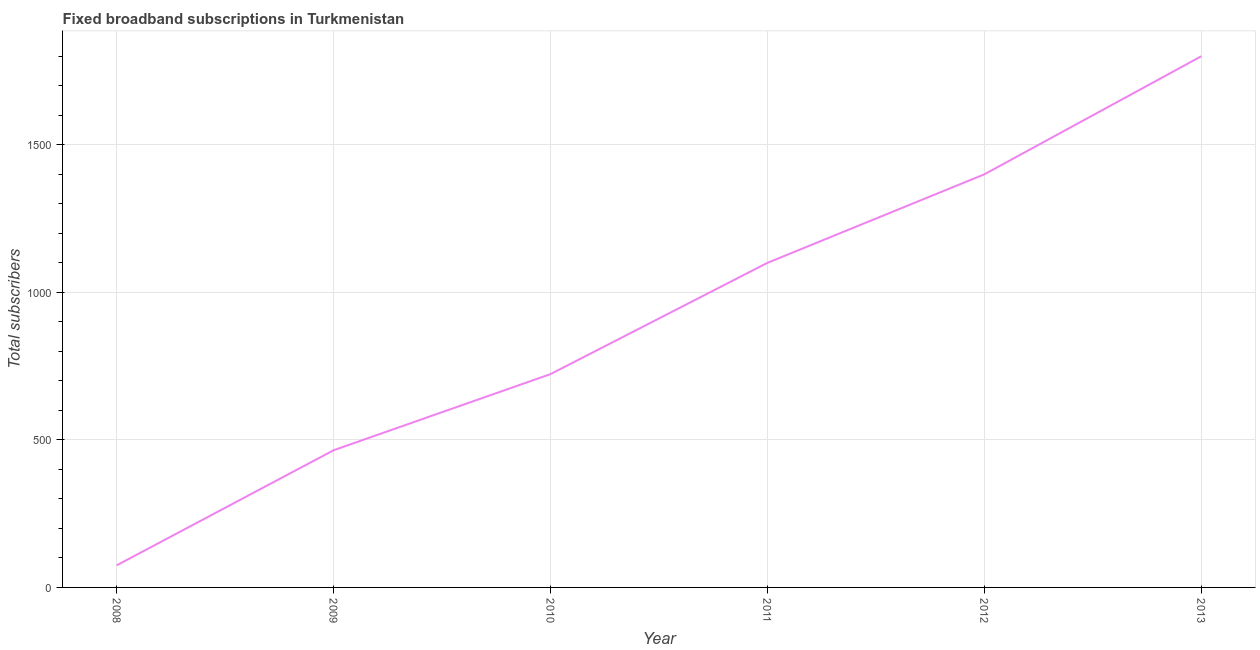What is the total number of fixed broadband subscriptions in 2010?
Your answer should be compact. 723. Across all years, what is the maximum total number of fixed broadband subscriptions?
Your answer should be very brief. 1800. Across all years, what is the minimum total number of fixed broadband subscriptions?
Provide a succinct answer. 75. In which year was the total number of fixed broadband subscriptions maximum?
Your answer should be compact. 2013. What is the sum of the total number of fixed broadband subscriptions?
Your answer should be very brief. 5563. What is the difference between the total number of fixed broadband subscriptions in 2008 and 2013?
Provide a succinct answer. -1725. What is the average total number of fixed broadband subscriptions per year?
Your response must be concise. 927.17. What is the median total number of fixed broadband subscriptions?
Keep it short and to the point. 911.5. What is the ratio of the total number of fixed broadband subscriptions in 2011 to that in 2012?
Your answer should be very brief. 0.79. Is the difference between the total number of fixed broadband subscriptions in 2008 and 2012 greater than the difference between any two years?
Provide a short and direct response. No. Is the sum of the total number of fixed broadband subscriptions in 2008 and 2010 greater than the maximum total number of fixed broadband subscriptions across all years?
Keep it short and to the point. No. What is the difference between the highest and the lowest total number of fixed broadband subscriptions?
Ensure brevity in your answer.  1725. In how many years, is the total number of fixed broadband subscriptions greater than the average total number of fixed broadband subscriptions taken over all years?
Provide a succinct answer. 3. Does the total number of fixed broadband subscriptions monotonically increase over the years?
Provide a succinct answer. Yes. How many lines are there?
Your response must be concise. 1. What is the difference between two consecutive major ticks on the Y-axis?
Give a very brief answer. 500. Are the values on the major ticks of Y-axis written in scientific E-notation?
Offer a terse response. No. What is the title of the graph?
Your response must be concise. Fixed broadband subscriptions in Turkmenistan. What is the label or title of the Y-axis?
Your answer should be compact. Total subscribers. What is the Total subscribers in 2009?
Ensure brevity in your answer.  465. What is the Total subscribers of 2010?
Your answer should be compact. 723. What is the Total subscribers of 2011?
Your answer should be very brief. 1100. What is the Total subscribers in 2012?
Your answer should be compact. 1400. What is the Total subscribers in 2013?
Give a very brief answer. 1800. What is the difference between the Total subscribers in 2008 and 2009?
Your answer should be very brief. -390. What is the difference between the Total subscribers in 2008 and 2010?
Make the answer very short. -648. What is the difference between the Total subscribers in 2008 and 2011?
Make the answer very short. -1025. What is the difference between the Total subscribers in 2008 and 2012?
Your answer should be very brief. -1325. What is the difference between the Total subscribers in 2008 and 2013?
Provide a succinct answer. -1725. What is the difference between the Total subscribers in 2009 and 2010?
Make the answer very short. -258. What is the difference between the Total subscribers in 2009 and 2011?
Make the answer very short. -635. What is the difference between the Total subscribers in 2009 and 2012?
Offer a very short reply. -935. What is the difference between the Total subscribers in 2009 and 2013?
Ensure brevity in your answer.  -1335. What is the difference between the Total subscribers in 2010 and 2011?
Give a very brief answer. -377. What is the difference between the Total subscribers in 2010 and 2012?
Ensure brevity in your answer.  -677. What is the difference between the Total subscribers in 2010 and 2013?
Your response must be concise. -1077. What is the difference between the Total subscribers in 2011 and 2012?
Offer a terse response. -300. What is the difference between the Total subscribers in 2011 and 2013?
Keep it short and to the point. -700. What is the difference between the Total subscribers in 2012 and 2013?
Give a very brief answer. -400. What is the ratio of the Total subscribers in 2008 to that in 2009?
Provide a short and direct response. 0.16. What is the ratio of the Total subscribers in 2008 to that in 2010?
Ensure brevity in your answer.  0.1. What is the ratio of the Total subscribers in 2008 to that in 2011?
Your answer should be compact. 0.07. What is the ratio of the Total subscribers in 2008 to that in 2012?
Offer a very short reply. 0.05. What is the ratio of the Total subscribers in 2008 to that in 2013?
Offer a terse response. 0.04. What is the ratio of the Total subscribers in 2009 to that in 2010?
Your response must be concise. 0.64. What is the ratio of the Total subscribers in 2009 to that in 2011?
Give a very brief answer. 0.42. What is the ratio of the Total subscribers in 2009 to that in 2012?
Keep it short and to the point. 0.33. What is the ratio of the Total subscribers in 2009 to that in 2013?
Offer a terse response. 0.26. What is the ratio of the Total subscribers in 2010 to that in 2011?
Keep it short and to the point. 0.66. What is the ratio of the Total subscribers in 2010 to that in 2012?
Provide a succinct answer. 0.52. What is the ratio of the Total subscribers in 2010 to that in 2013?
Give a very brief answer. 0.4. What is the ratio of the Total subscribers in 2011 to that in 2012?
Offer a terse response. 0.79. What is the ratio of the Total subscribers in 2011 to that in 2013?
Your answer should be very brief. 0.61. What is the ratio of the Total subscribers in 2012 to that in 2013?
Ensure brevity in your answer.  0.78. 